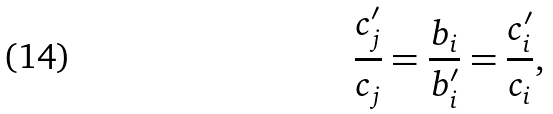<formula> <loc_0><loc_0><loc_500><loc_500>\frac { c _ { j } ^ { \prime } } { c _ { j } } = \frac { b _ { i } } { b _ { i } ^ { \prime } } = \frac { c _ { i } ^ { \prime } } { c _ { i } } ,</formula> 